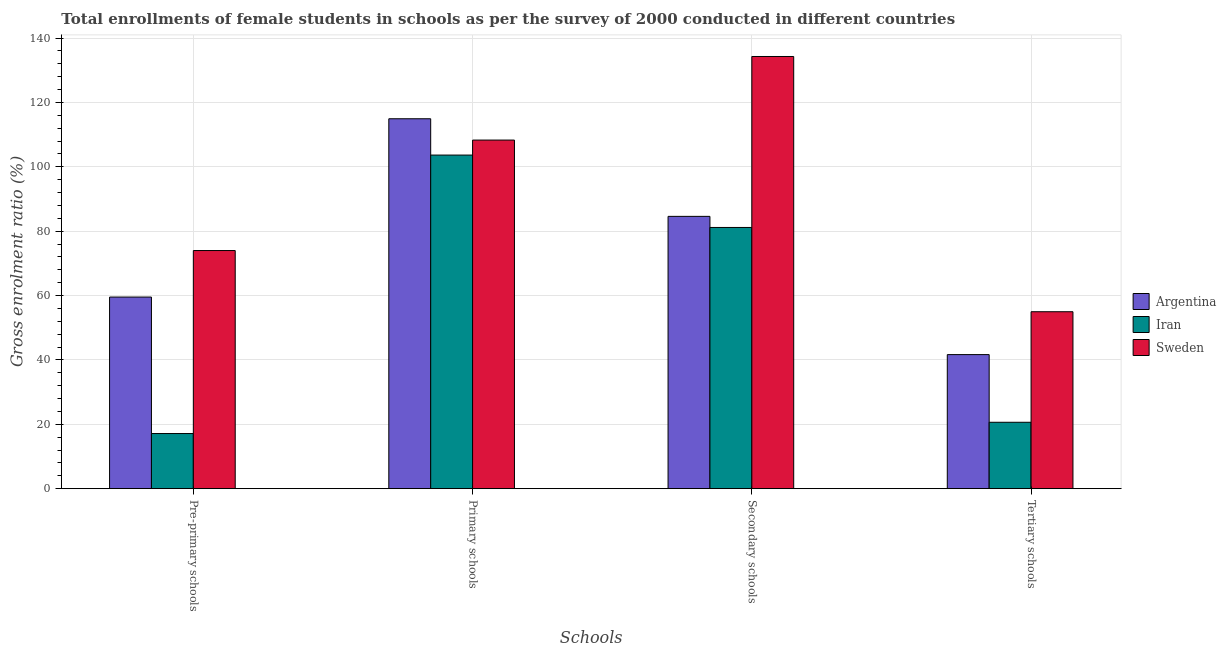How many groups of bars are there?
Make the answer very short. 4. Are the number of bars per tick equal to the number of legend labels?
Provide a succinct answer. Yes. How many bars are there on the 1st tick from the right?
Your answer should be very brief. 3. What is the label of the 3rd group of bars from the left?
Provide a succinct answer. Secondary schools. What is the gross enrolment ratio(female) in tertiary schools in Sweden?
Provide a short and direct response. 54.97. Across all countries, what is the maximum gross enrolment ratio(female) in tertiary schools?
Keep it short and to the point. 54.97. Across all countries, what is the minimum gross enrolment ratio(female) in pre-primary schools?
Give a very brief answer. 17.13. In which country was the gross enrolment ratio(female) in primary schools maximum?
Your answer should be compact. Argentina. In which country was the gross enrolment ratio(female) in primary schools minimum?
Your response must be concise. Iran. What is the total gross enrolment ratio(female) in primary schools in the graph?
Your answer should be compact. 326.88. What is the difference between the gross enrolment ratio(female) in pre-primary schools in Sweden and that in Argentina?
Offer a terse response. 14.46. What is the difference between the gross enrolment ratio(female) in pre-primary schools in Argentina and the gross enrolment ratio(female) in secondary schools in Sweden?
Give a very brief answer. -74.74. What is the average gross enrolment ratio(female) in pre-primary schools per country?
Your answer should be very brief. 50.22. What is the difference between the gross enrolment ratio(female) in secondary schools and gross enrolment ratio(female) in tertiary schools in Argentina?
Provide a succinct answer. 42.94. In how many countries, is the gross enrolment ratio(female) in primary schools greater than 36 %?
Provide a short and direct response. 3. What is the ratio of the gross enrolment ratio(female) in primary schools in Argentina to that in Iran?
Give a very brief answer. 1.11. Is the gross enrolment ratio(female) in tertiary schools in Iran less than that in Sweden?
Provide a succinct answer. Yes. What is the difference between the highest and the second highest gross enrolment ratio(female) in pre-primary schools?
Provide a short and direct response. 14.46. What is the difference between the highest and the lowest gross enrolment ratio(female) in secondary schools?
Offer a terse response. 53.12. Is the sum of the gross enrolment ratio(female) in primary schools in Sweden and Iran greater than the maximum gross enrolment ratio(female) in secondary schools across all countries?
Your answer should be very brief. Yes. Is it the case that in every country, the sum of the gross enrolment ratio(female) in secondary schools and gross enrolment ratio(female) in tertiary schools is greater than the sum of gross enrolment ratio(female) in primary schools and gross enrolment ratio(female) in pre-primary schools?
Provide a succinct answer. No. What does the 2nd bar from the left in Tertiary schools represents?
Your answer should be very brief. Iran. What does the 3rd bar from the right in Primary schools represents?
Offer a terse response. Argentina. Is it the case that in every country, the sum of the gross enrolment ratio(female) in pre-primary schools and gross enrolment ratio(female) in primary schools is greater than the gross enrolment ratio(female) in secondary schools?
Provide a succinct answer. Yes. How many bars are there?
Your answer should be compact. 12. How many countries are there in the graph?
Provide a succinct answer. 3. Does the graph contain grids?
Offer a very short reply. Yes. How many legend labels are there?
Ensure brevity in your answer.  3. How are the legend labels stacked?
Your response must be concise. Vertical. What is the title of the graph?
Offer a very short reply. Total enrollments of female students in schools as per the survey of 2000 conducted in different countries. What is the label or title of the X-axis?
Offer a terse response. Schools. What is the label or title of the Y-axis?
Your answer should be very brief. Gross enrolment ratio (%). What is the Gross enrolment ratio (%) of Argentina in Pre-primary schools?
Give a very brief answer. 59.53. What is the Gross enrolment ratio (%) in Iran in Pre-primary schools?
Ensure brevity in your answer.  17.13. What is the Gross enrolment ratio (%) of Sweden in Pre-primary schools?
Keep it short and to the point. 73.99. What is the Gross enrolment ratio (%) in Argentina in Primary schools?
Ensure brevity in your answer.  114.93. What is the Gross enrolment ratio (%) of Iran in Primary schools?
Keep it short and to the point. 103.65. What is the Gross enrolment ratio (%) in Sweden in Primary schools?
Keep it short and to the point. 108.31. What is the Gross enrolment ratio (%) of Argentina in Secondary schools?
Make the answer very short. 84.6. What is the Gross enrolment ratio (%) of Iran in Secondary schools?
Offer a very short reply. 81.16. What is the Gross enrolment ratio (%) of Sweden in Secondary schools?
Offer a terse response. 134.27. What is the Gross enrolment ratio (%) in Argentina in Tertiary schools?
Offer a terse response. 41.66. What is the Gross enrolment ratio (%) in Iran in Tertiary schools?
Give a very brief answer. 20.63. What is the Gross enrolment ratio (%) in Sweden in Tertiary schools?
Provide a succinct answer. 54.97. Across all Schools, what is the maximum Gross enrolment ratio (%) of Argentina?
Provide a succinct answer. 114.93. Across all Schools, what is the maximum Gross enrolment ratio (%) in Iran?
Keep it short and to the point. 103.65. Across all Schools, what is the maximum Gross enrolment ratio (%) of Sweden?
Make the answer very short. 134.27. Across all Schools, what is the minimum Gross enrolment ratio (%) in Argentina?
Keep it short and to the point. 41.66. Across all Schools, what is the minimum Gross enrolment ratio (%) of Iran?
Keep it short and to the point. 17.13. Across all Schools, what is the minimum Gross enrolment ratio (%) of Sweden?
Offer a very short reply. 54.97. What is the total Gross enrolment ratio (%) in Argentina in the graph?
Ensure brevity in your answer.  300.72. What is the total Gross enrolment ratio (%) of Iran in the graph?
Your response must be concise. 222.56. What is the total Gross enrolment ratio (%) of Sweden in the graph?
Ensure brevity in your answer.  371.54. What is the difference between the Gross enrolment ratio (%) in Argentina in Pre-primary schools and that in Primary schools?
Ensure brevity in your answer.  -55.4. What is the difference between the Gross enrolment ratio (%) in Iran in Pre-primary schools and that in Primary schools?
Ensure brevity in your answer.  -86.51. What is the difference between the Gross enrolment ratio (%) of Sweden in Pre-primary schools and that in Primary schools?
Your answer should be very brief. -34.32. What is the difference between the Gross enrolment ratio (%) in Argentina in Pre-primary schools and that in Secondary schools?
Offer a terse response. -25.07. What is the difference between the Gross enrolment ratio (%) of Iran in Pre-primary schools and that in Secondary schools?
Provide a succinct answer. -64.02. What is the difference between the Gross enrolment ratio (%) of Sweden in Pre-primary schools and that in Secondary schools?
Ensure brevity in your answer.  -60.29. What is the difference between the Gross enrolment ratio (%) in Argentina in Pre-primary schools and that in Tertiary schools?
Ensure brevity in your answer.  17.88. What is the difference between the Gross enrolment ratio (%) of Iran in Pre-primary schools and that in Tertiary schools?
Provide a succinct answer. -3.5. What is the difference between the Gross enrolment ratio (%) in Sweden in Pre-primary schools and that in Tertiary schools?
Give a very brief answer. 19.01. What is the difference between the Gross enrolment ratio (%) in Argentina in Primary schools and that in Secondary schools?
Offer a very short reply. 30.33. What is the difference between the Gross enrolment ratio (%) of Iran in Primary schools and that in Secondary schools?
Offer a terse response. 22.49. What is the difference between the Gross enrolment ratio (%) in Sweden in Primary schools and that in Secondary schools?
Provide a short and direct response. -25.97. What is the difference between the Gross enrolment ratio (%) of Argentina in Primary schools and that in Tertiary schools?
Keep it short and to the point. 73.27. What is the difference between the Gross enrolment ratio (%) in Iran in Primary schools and that in Tertiary schools?
Make the answer very short. 83.01. What is the difference between the Gross enrolment ratio (%) of Sweden in Primary schools and that in Tertiary schools?
Provide a succinct answer. 53.33. What is the difference between the Gross enrolment ratio (%) in Argentina in Secondary schools and that in Tertiary schools?
Ensure brevity in your answer.  42.94. What is the difference between the Gross enrolment ratio (%) of Iran in Secondary schools and that in Tertiary schools?
Make the answer very short. 60.52. What is the difference between the Gross enrolment ratio (%) of Sweden in Secondary schools and that in Tertiary schools?
Your response must be concise. 79.3. What is the difference between the Gross enrolment ratio (%) in Argentina in Pre-primary schools and the Gross enrolment ratio (%) in Iran in Primary schools?
Your answer should be very brief. -44.11. What is the difference between the Gross enrolment ratio (%) of Argentina in Pre-primary schools and the Gross enrolment ratio (%) of Sweden in Primary schools?
Make the answer very short. -48.77. What is the difference between the Gross enrolment ratio (%) in Iran in Pre-primary schools and the Gross enrolment ratio (%) in Sweden in Primary schools?
Provide a succinct answer. -91.17. What is the difference between the Gross enrolment ratio (%) of Argentina in Pre-primary schools and the Gross enrolment ratio (%) of Iran in Secondary schools?
Your answer should be very brief. -21.62. What is the difference between the Gross enrolment ratio (%) in Argentina in Pre-primary schools and the Gross enrolment ratio (%) in Sweden in Secondary schools?
Your answer should be compact. -74.74. What is the difference between the Gross enrolment ratio (%) of Iran in Pre-primary schools and the Gross enrolment ratio (%) of Sweden in Secondary schools?
Provide a succinct answer. -117.14. What is the difference between the Gross enrolment ratio (%) of Argentina in Pre-primary schools and the Gross enrolment ratio (%) of Iran in Tertiary schools?
Your response must be concise. 38.9. What is the difference between the Gross enrolment ratio (%) in Argentina in Pre-primary schools and the Gross enrolment ratio (%) in Sweden in Tertiary schools?
Offer a very short reply. 4.56. What is the difference between the Gross enrolment ratio (%) of Iran in Pre-primary schools and the Gross enrolment ratio (%) of Sweden in Tertiary schools?
Ensure brevity in your answer.  -37.84. What is the difference between the Gross enrolment ratio (%) in Argentina in Primary schools and the Gross enrolment ratio (%) in Iran in Secondary schools?
Your response must be concise. 33.77. What is the difference between the Gross enrolment ratio (%) of Argentina in Primary schools and the Gross enrolment ratio (%) of Sweden in Secondary schools?
Your answer should be very brief. -19.35. What is the difference between the Gross enrolment ratio (%) of Iran in Primary schools and the Gross enrolment ratio (%) of Sweden in Secondary schools?
Provide a short and direct response. -30.63. What is the difference between the Gross enrolment ratio (%) in Argentina in Primary schools and the Gross enrolment ratio (%) in Iran in Tertiary schools?
Your response must be concise. 94.3. What is the difference between the Gross enrolment ratio (%) in Argentina in Primary schools and the Gross enrolment ratio (%) in Sweden in Tertiary schools?
Offer a terse response. 59.95. What is the difference between the Gross enrolment ratio (%) of Iran in Primary schools and the Gross enrolment ratio (%) of Sweden in Tertiary schools?
Your answer should be very brief. 48.67. What is the difference between the Gross enrolment ratio (%) of Argentina in Secondary schools and the Gross enrolment ratio (%) of Iran in Tertiary schools?
Offer a very short reply. 63.97. What is the difference between the Gross enrolment ratio (%) of Argentina in Secondary schools and the Gross enrolment ratio (%) of Sweden in Tertiary schools?
Your answer should be compact. 29.63. What is the difference between the Gross enrolment ratio (%) in Iran in Secondary schools and the Gross enrolment ratio (%) in Sweden in Tertiary schools?
Make the answer very short. 26.18. What is the average Gross enrolment ratio (%) of Argentina per Schools?
Offer a terse response. 75.18. What is the average Gross enrolment ratio (%) of Iran per Schools?
Your answer should be very brief. 55.64. What is the average Gross enrolment ratio (%) of Sweden per Schools?
Ensure brevity in your answer.  92.89. What is the difference between the Gross enrolment ratio (%) of Argentina and Gross enrolment ratio (%) of Iran in Pre-primary schools?
Give a very brief answer. 42.4. What is the difference between the Gross enrolment ratio (%) in Argentina and Gross enrolment ratio (%) in Sweden in Pre-primary schools?
Provide a short and direct response. -14.46. What is the difference between the Gross enrolment ratio (%) of Iran and Gross enrolment ratio (%) of Sweden in Pre-primary schools?
Make the answer very short. -56.86. What is the difference between the Gross enrolment ratio (%) of Argentina and Gross enrolment ratio (%) of Iran in Primary schools?
Keep it short and to the point. 11.28. What is the difference between the Gross enrolment ratio (%) in Argentina and Gross enrolment ratio (%) in Sweden in Primary schools?
Offer a very short reply. 6.62. What is the difference between the Gross enrolment ratio (%) of Iran and Gross enrolment ratio (%) of Sweden in Primary schools?
Offer a very short reply. -4.66. What is the difference between the Gross enrolment ratio (%) of Argentina and Gross enrolment ratio (%) of Iran in Secondary schools?
Keep it short and to the point. 3.44. What is the difference between the Gross enrolment ratio (%) in Argentina and Gross enrolment ratio (%) in Sweden in Secondary schools?
Ensure brevity in your answer.  -49.67. What is the difference between the Gross enrolment ratio (%) in Iran and Gross enrolment ratio (%) in Sweden in Secondary schools?
Provide a short and direct response. -53.12. What is the difference between the Gross enrolment ratio (%) of Argentina and Gross enrolment ratio (%) of Iran in Tertiary schools?
Make the answer very short. 21.02. What is the difference between the Gross enrolment ratio (%) in Argentina and Gross enrolment ratio (%) in Sweden in Tertiary schools?
Ensure brevity in your answer.  -13.32. What is the difference between the Gross enrolment ratio (%) in Iran and Gross enrolment ratio (%) in Sweden in Tertiary schools?
Your answer should be very brief. -34.34. What is the ratio of the Gross enrolment ratio (%) of Argentina in Pre-primary schools to that in Primary schools?
Make the answer very short. 0.52. What is the ratio of the Gross enrolment ratio (%) in Iran in Pre-primary schools to that in Primary schools?
Your response must be concise. 0.17. What is the ratio of the Gross enrolment ratio (%) in Sweden in Pre-primary schools to that in Primary schools?
Keep it short and to the point. 0.68. What is the ratio of the Gross enrolment ratio (%) of Argentina in Pre-primary schools to that in Secondary schools?
Your answer should be very brief. 0.7. What is the ratio of the Gross enrolment ratio (%) of Iran in Pre-primary schools to that in Secondary schools?
Keep it short and to the point. 0.21. What is the ratio of the Gross enrolment ratio (%) in Sweden in Pre-primary schools to that in Secondary schools?
Offer a very short reply. 0.55. What is the ratio of the Gross enrolment ratio (%) of Argentina in Pre-primary schools to that in Tertiary schools?
Your answer should be compact. 1.43. What is the ratio of the Gross enrolment ratio (%) of Iran in Pre-primary schools to that in Tertiary schools?
Keep it short and to the point. 0.83. What is the ratio of the Gross enrolment ratio (%) in Sweden in Pre-primary schools to that in Tertiary schools?
Make the answer very short. 1.35. What is the ratio of the Gross enrolment ratio (%) in Argentina in Primary schools to that in Secondary schools?
Offer a very short reply. 1.36. What is the ratio of the Gross enrolment ratio (%) in Iran in Primary schools to that in Secondary schools?
Offer a very short reply. 1.28. What is the ratio of the Gross enrolment ratio (%) in Sweden in Primary schools to that in Secondary schools?
Provide a succinct answer. 0.81. What is the ratio of the Gross enrolment ratio (%) of Argentina in Primary schools to that in Tertiary schools?
Your response must be concise. 2.76. What is the ratio of the Gross enrolment ratio (%) in Iran in Primary schools to that in Tertiary schools?
Offer a terse response. 5.02. What is the ratio of the Gross enrolment ratio (%) in Sweden in Primary schools to that in Tertiary schools?
Make the answer very short. 1.97. What is the ratio of the Gross enrolment ratio (%) of Argentina in Secondary schools to that in Tertiary schools?
Keep it short and to the point. 2.03. What is the ratio of the Gross enrolment ratio (%) in Iran in Secondary schools to that in Tertiary schools?
Keep it short and to the point. 3.93. What is the ratio of the Gross enrolment ratio (%) of Sweden in Secondary schools to that in Tertiary schools?
Make the answer very short. 2.44. What is the difference between the highest and the second highest Gross enrolment ratio (%) of Argentina?
Your answer should be very brief. 30.33. What is the difference between the highest and the second highest Gross enrolment ratio (%) in Iran?
Provide a short and direct response. 22.49. What is the difference between the highest and the second highest Gross enrolment ratio (%) of Sweden?
Your answer should be compact. 25.97. What is the difference between the highest and the lowest Gross enrolment ratio (%) in Argentina?
Your answer should be very brief. 73.27. What is the difference between the highest and the lowest Gross enrolment ratio (%) of Iran?
Offer a terse response. 86.51. What is the difference between the highest and the lowest Gross enrolment ratio (%) in Sweden?
Offer a terse response. 79.3. 